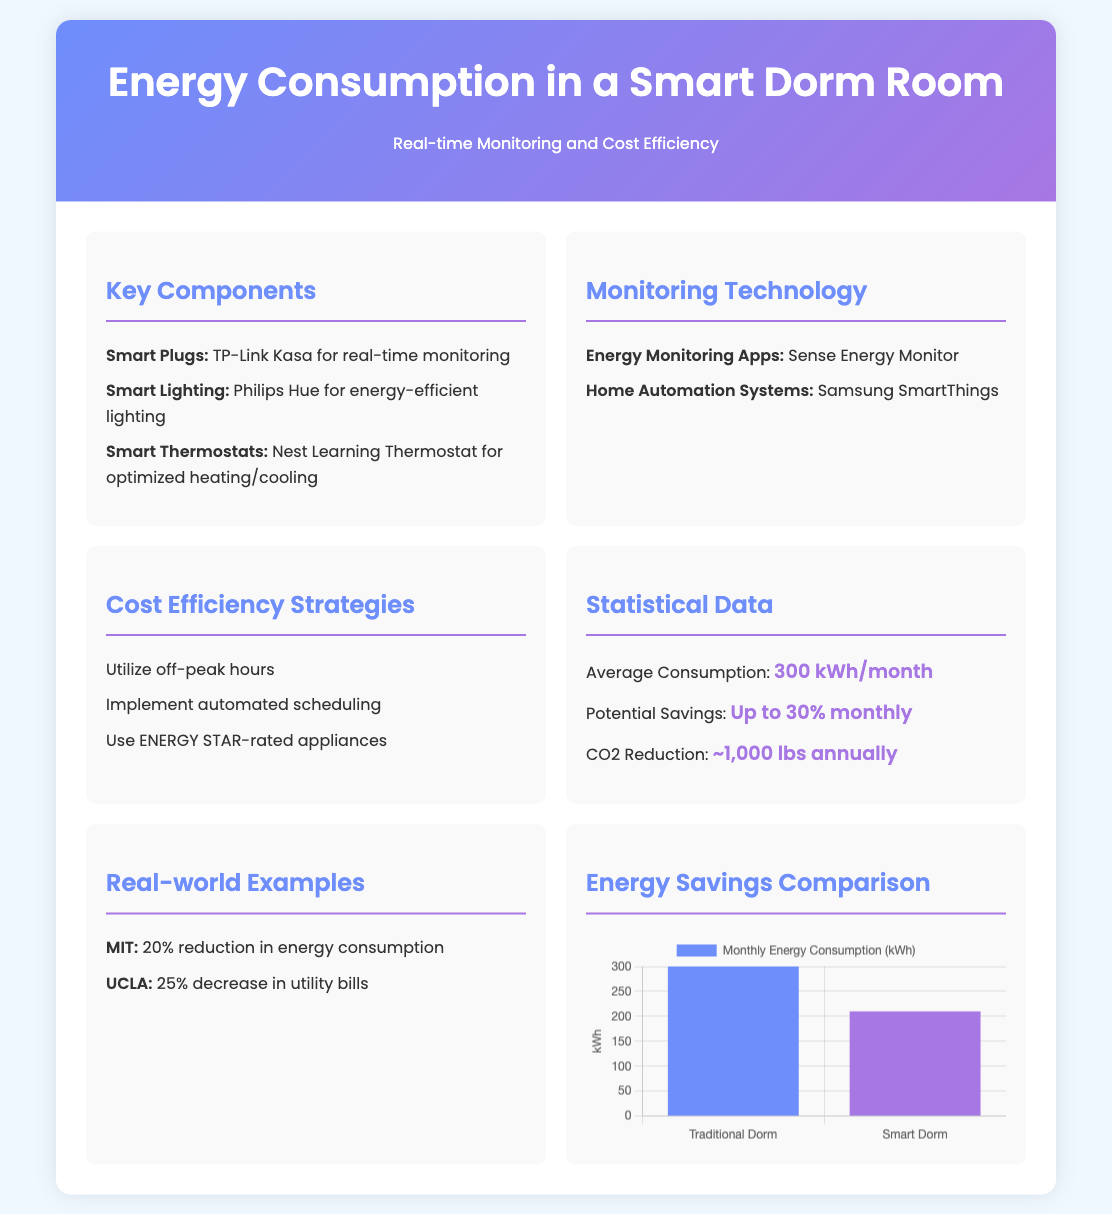what is the average energy consumption in a smart dorm room? The average consumption listed in the document is 300 kWh/month.
Answer: 300 kWh/month what is the potential savings in energy costs? The document states a potential savings of up to 30% monthly.
Answer: Up to 30% monthly which smart plug is recommended for real-time monitoring? The document mentions TP-Link Kasa as the smart plug for real-time monitoring.
Answer: TP-Link Kasa how much CO2 reduction is expected annually? The expected CO2 reduction mentioned in the document is approximately 1,000 lbs annually.
Answer: ~1,000 lbs annually what percentage reduction in energy consumption did MIT achieve? According to the document, MIT achieved a 20% reduction in energy consumption.
Answer: 20% what is the monthly energy consumption of a traditional dorm? The document provides a monthly energy consumption of 300 kWh for a traditional dorm.
Answer: 300 kWh what is the primary mental model for energy cost efficiency? The document identifies cost efficiency strategies including utilizing off-peak hours, among others.
Answer: Utilizing off-peak hours how much energy does a smart dorm consume according to the chart? The chart shows that a smart dorm consumes 210 kWh per month.
Answer: 210 kWh what background color is used for the container? The background color specified for the container in the document is white.
Answer: White 